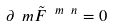Convert formula to latex. <formula><loc_0><loc_0><loc_500><loc_500>\partial _ { \ } m \tilde { F } ^ { \ m \ n } = 0</formula> 